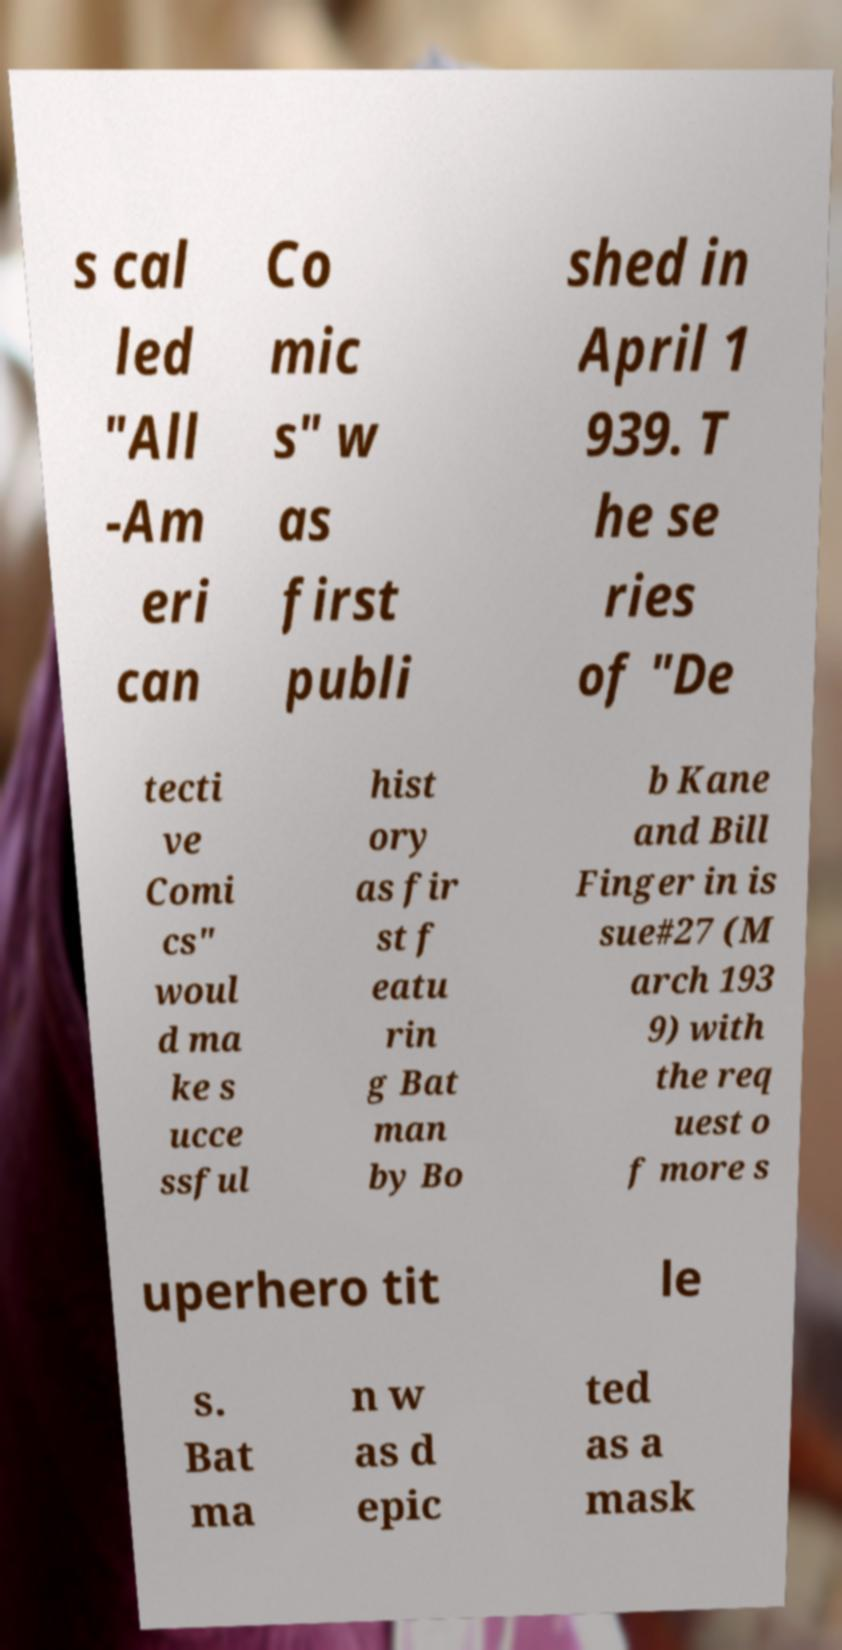Please read and relay the text visible in this image. What does it say? s cal led "All -Am eri can Co mic s" w as first publi shed in April 1 939. T he se ries of "De tecti ve Comi cs" woul d ma ke s ucce ssful hist ory as fir st f eatu rin g Bat man by Bo b Kane and Bill Finger in is sue#27 (M arch 193 9) with the req uest o f more s uperhero tit le s. Bat ma n w as d epic ted as a mask 